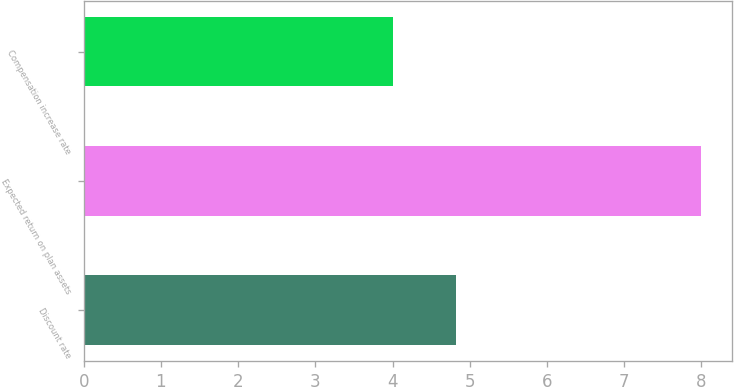<chart> <loc_0><loc_0><loc_500><loc_500><bar_chart><fcel>Discount rate<fcel>Expected return on plan assets<fcel>Compensation increase rate<nl><fcel>4.82<fcel>8<fcel>4<nl></chart> 